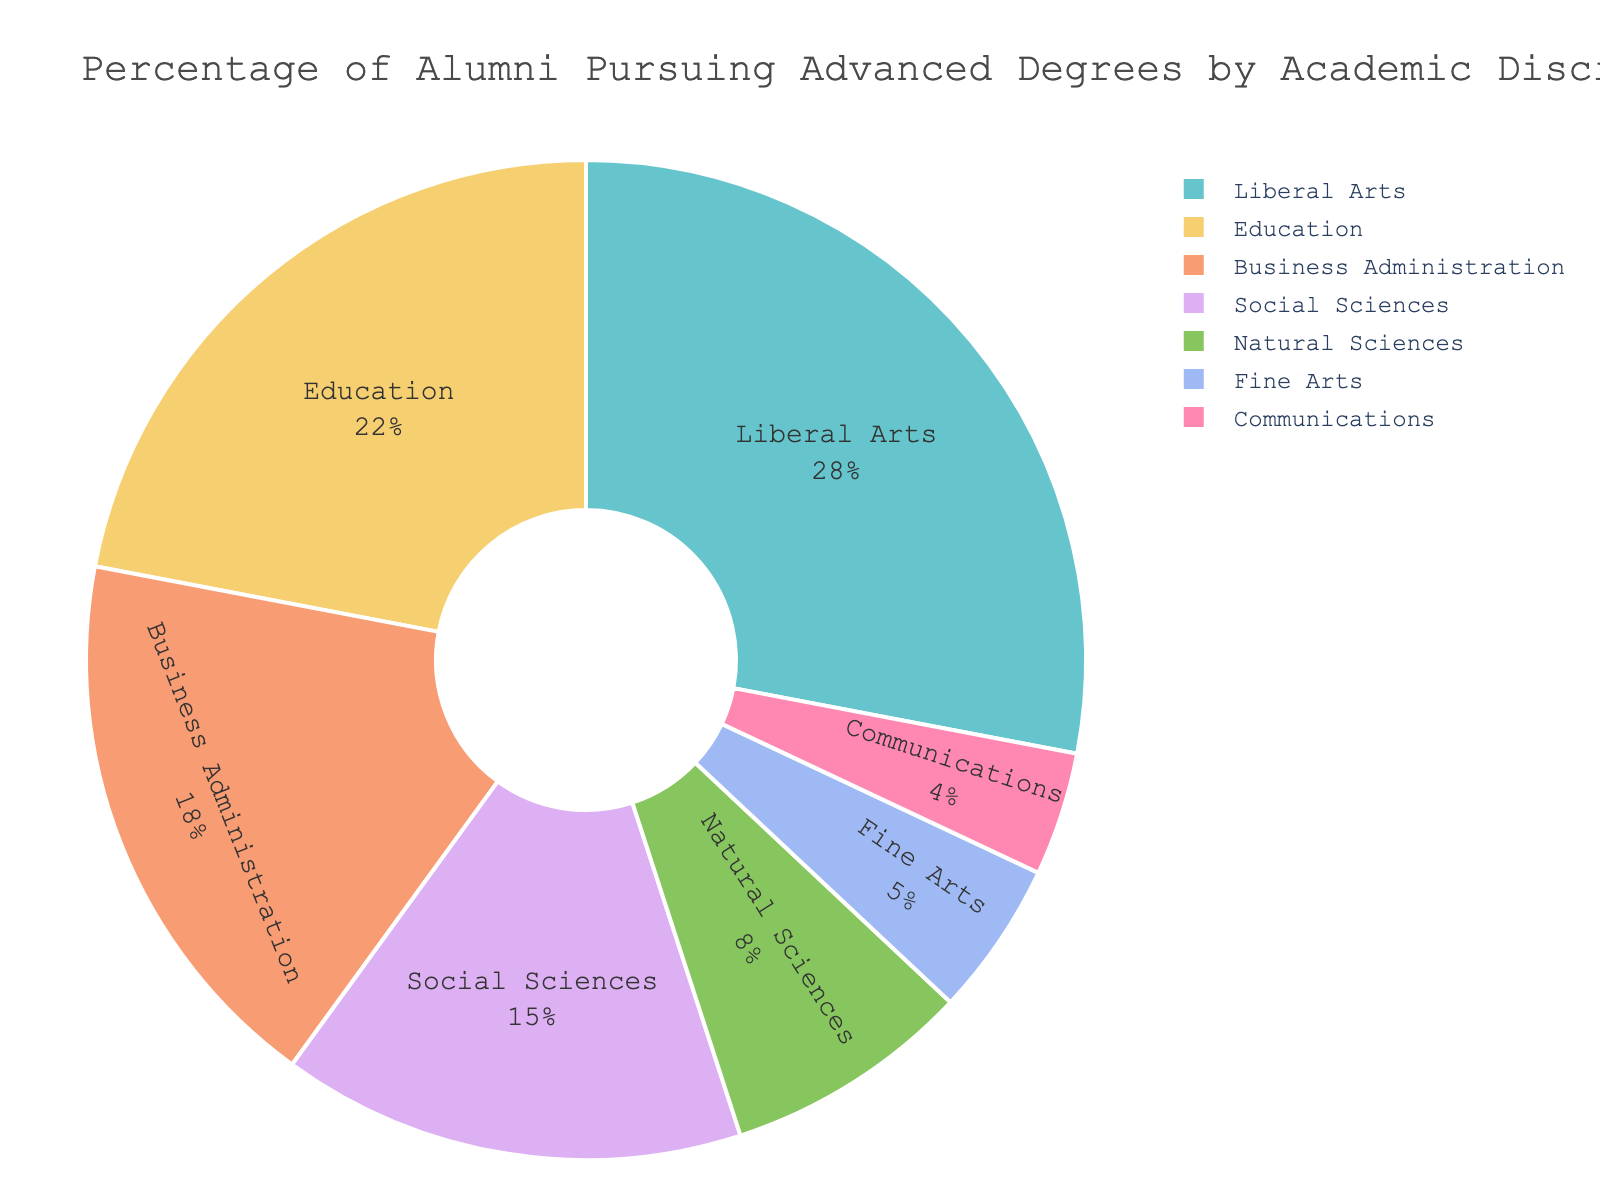Which academic discipline has the highest percentage of alumni pursuing advanced degrees? The discipline with the largest slice of the pie chart represents the highest percentage. Liberal Arts has the largest slice.
Answer: Liberal Arts What is the combined percentage of alumni pursuing advanced degrees in Liberal Arts and Education? Add the percentages of Liberal Arts and Education (28% + 22%).
Answer: 50% Which discipline has a lower percentage of alumni pursuing advanced degrees: Natural Sciences or Fine Arts? Compare the percentages of Natural Sciences (8%) and Fine Arts (5%).
Answer: Fine Arts What percentage more alumni pursue advanced degrees in Business Administration compared to Communications? Subtract the percentage of Communications from Business Administration (18% - 4%).
Answer: 14% What is the difference between the percentage of alumni pursuing advanced degrees in Social Sciences and Fine Arts? Subtract the percentage of Fine Arts from Social Sciences (15% - 5%).
Answer: 10% Which disciplines collectively constitute exactly half of the alumni pursuing advanced degrees? Sum percentages of disciplines until 50% is reached. Liberal Arts and Education together make 50% (28% + 22%).
Answer: Liberal Arts and Education What is the second highest percentage of alumni pursuing advanced degrees, and in which discipline? Identify the second largest slice after Liberal Arts. Education has the second highest percentage at 22%.
Answer: Education, 22% How much lower is the percentage of alumni pursuing advanced degrees in Communications compared to Natural Sciences? Subtract the percentage of Communications from Natural Sciences (8% - 4%).
Answer: 4% What disciplines have less than 10% of alumni pursuing advanced degrees? Identify slices representing less than 10%. Natural Sciences (8%), Fine Arts (5%), and Communications (4%).
Answer: Natural Sciences, Fine Arts, Communications By how much does the combined percentage of alumni pursuing advanced degrees in Social Sciences and Fine Arts exceed that in Communications? Add the percentages of Social Sciences and Fine Arts, then subtract the percentage of Communications: (15% + 5%) - 4% = 16%.
Answer: 16% 